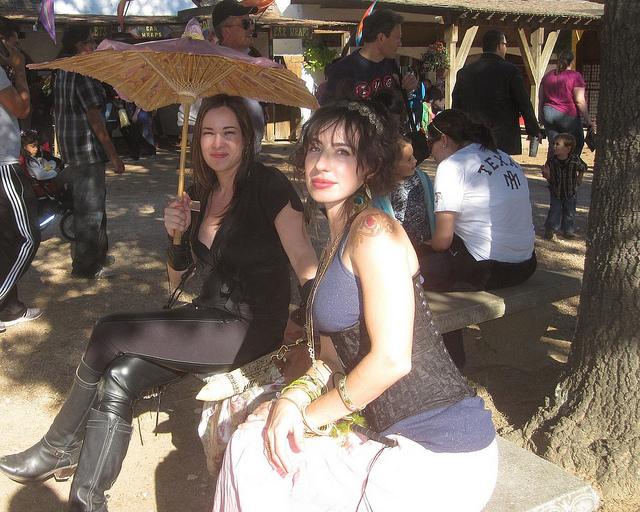What are the women sitting under?
Be succinct. Tree. What color are the boots?
Answer briefly. Black. Is the woman in the foreground wearing makeup?
Concise answer only. Yes. 